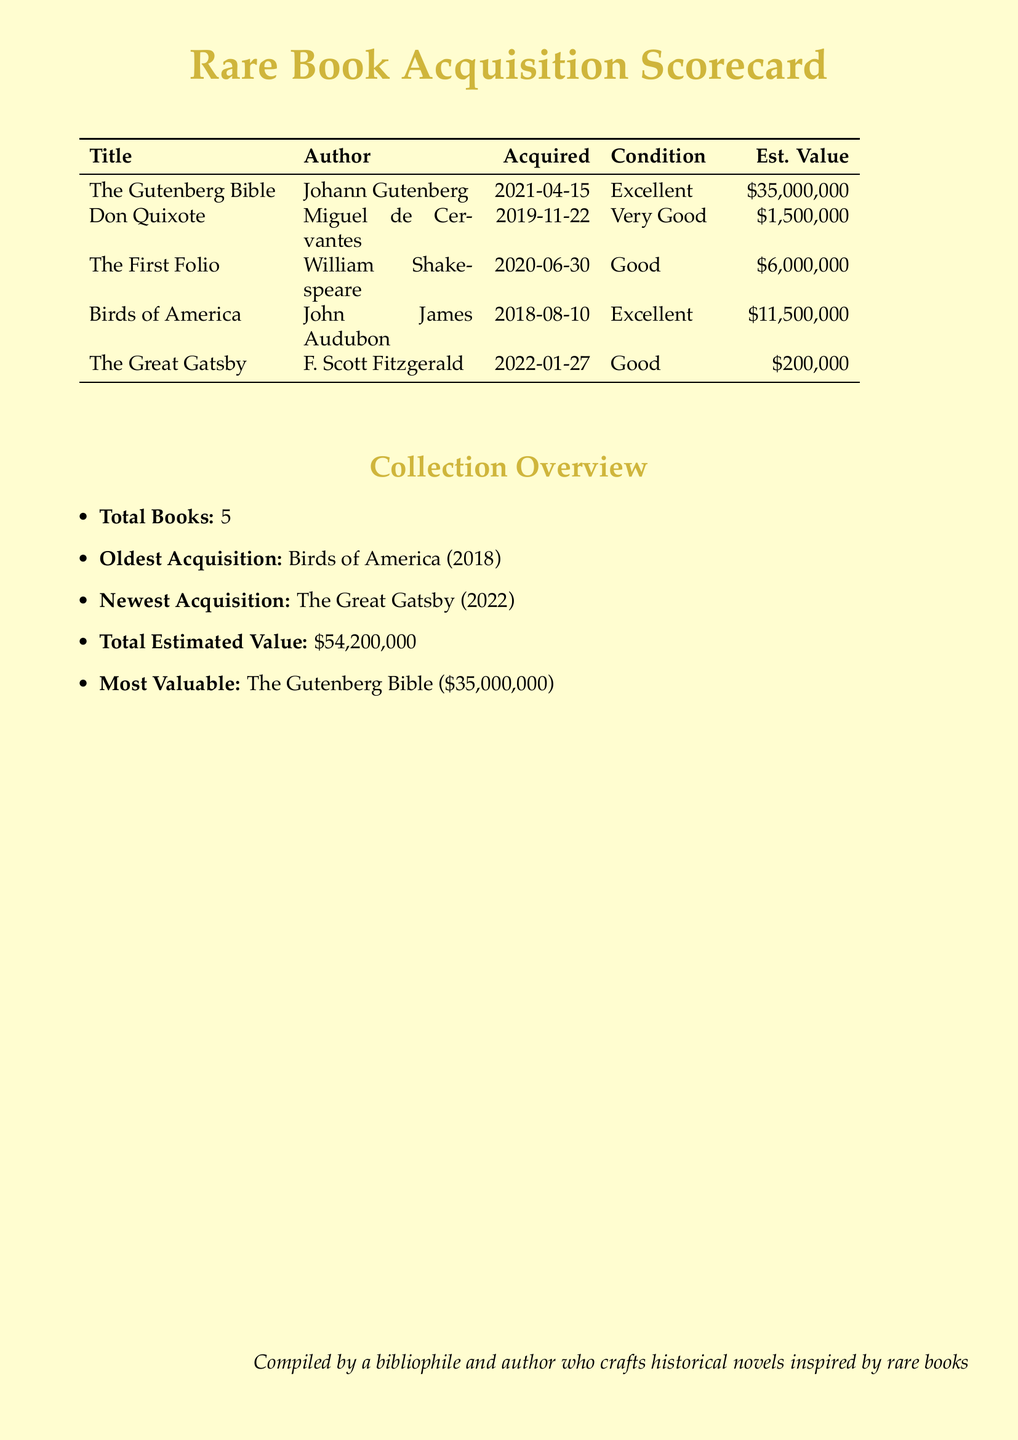What is the title of the most valuable book? The document states that the most valuable book is The Gutenberg Bible, which is listed in the table.
Answer: The Gutenberg Bible How many books are listed in the scorecard? The total number of books is provided in the collection overview section of the document, which states there are 5 books.
Answer: 5 What is the acquisition date of Don Quixote? The acquisition date for Don Quixote is listed in the table, under the column "Acquired" for that book.
Answer: 2019-11-22 What is the estimated value of The First Folio? The estimated value for The First Folio is given in the document under the "Est. Value" column.
Answer: $6,000,000 Which book has the oldest acquisition date? The document specifies the oldest acquisition in the collection overview section, identifying Birds of America as the oldest.
Answer: Birds of America What condition is The Great Gatsby in? The condition of The Great Gatsby is displayed in the table under the "Condition" column, specifically noted for that book.
Answer: Good How much is the total estimated value of all books? The total estimated value is summarized in the collection overview section of the document as the sum of individual book values.
Answer: $54,200,000 What date was Birds of America acquired? The acquisition date for Birds of America is directly indicated in the table under the "Acquired" column.
Answer: 2018-08-10 